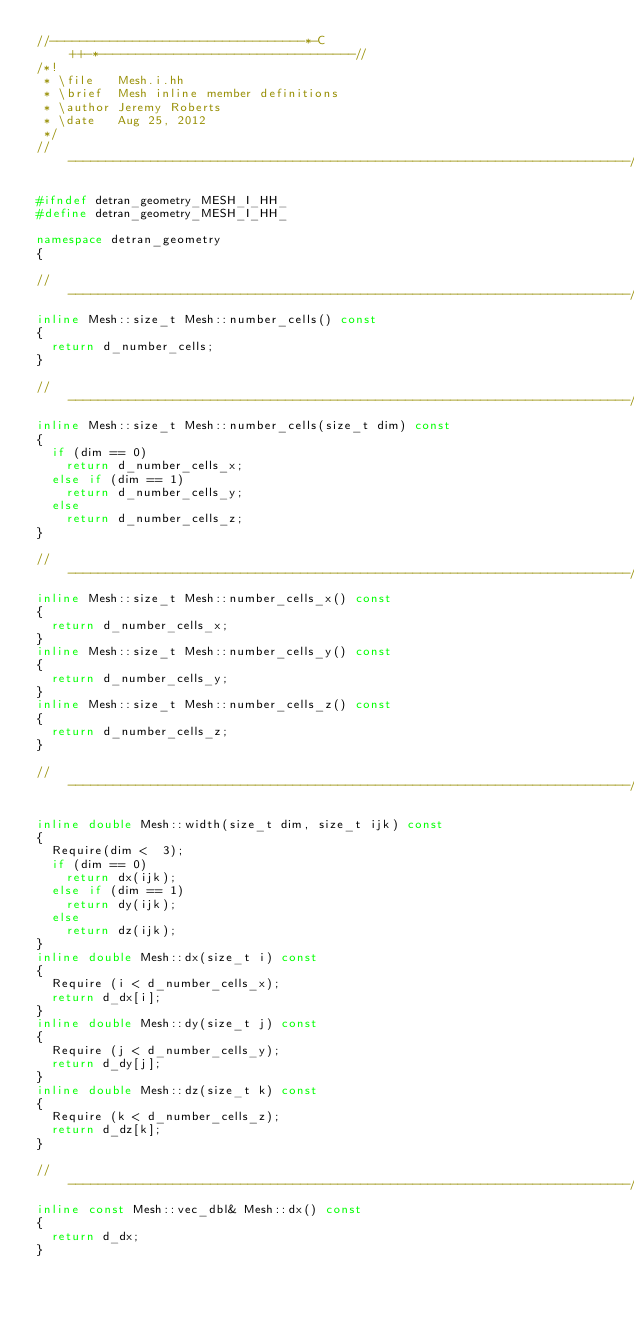<code> <loc_0><loc_0><loc_500><loc_500><_C++_>//----------------------------------*-C++-*----------------------------------//
/*!
 * \file   Mesh.i.hh
 * \brief  Mesh inline member definitions
 * \author Jeremy Roberts
 * \date   Aug 25, 2012
 */
//---------------------------------------------------------------------------//

#ifndef detran_geometry_MESH_I_HH_
#define detran_geometry_MESH_I_HH_

namespace detran_geometry
{

//---------------------------------------------------------------------------//
inline Mesh::size_t Mesh::number_cells() const
{
  return d_number_cells;
}

//---------------------------------------------------------------------------//
inline Mesh::size_t Mesh::number_cells(size_t dim) const
{
  if (dim == 0)
    return d_number_cells_x;
  else if (dim == 1)
    return d_number_cells_y;
  else
    return d_number_cells_z;
}

//---------------------------------------------------------------------------//
inline Mesh::size_t Mesh::number_cells_x() const
{
  return d_number_cells_x;
}
inline Mesh::size_t Mesh::number_cells_y() const
{
  return d_number_cells_y;
}
inline Mesh::size_t Mesh::number_cells_z() const
{
  return d_number_cells_z;
}

//---------------------------------------------------------------------------//

inline double Mesh::width(size_t dim, size_t ijk) const
{
  Require(dim <  3);
  if (dim == 0)
    return dx(ijk);
  else if (dim == 1)
    return dy(ijk);
  else
    return dz(ijk);
}
inline double Mesh::dx(size_t i) const
{
  Require (i < d_number_cells_x);
  return d_dx[i];
}
inline double Mesh::dy(size_t j) const
{
  Require (j < d_number_cells_y);
  return d_dy[j];
}
inline double Mesh::dz(size_t k) const
{
  Require (k < d_number_cells_z);
  return d_dz[k];
}

//---------------------------------------------------------------------------//
inline const Mesh::vec_dbl& Mesh::dx() const
{
  return d_dx;
}</code> 